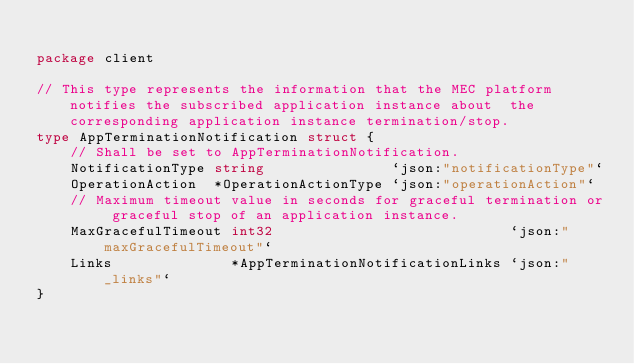<code> <loc_0><loc_0><loc_500><loc_500><_Go_>
package client

// This type represents the information that the MEC platform notifies the subscribed application instance about  the corresponding application instance termination/stop.
type AppTerminationNotification struct {
	// Shall be set to AppTerminationNotification.
	NotificationType string               `json:"notificationType"`
	OperationAction  *OperationActionType `json:"operationAction"`
	// Maximum timeout value in seconds for graceful termination or graceful stop of an application instance.
	MaxGracefulTimeout int32                            `json:"maxGracefulTimeout"`
	Links              *AppTerminationNotificationLinks `json:"_links"`
}
</code> 